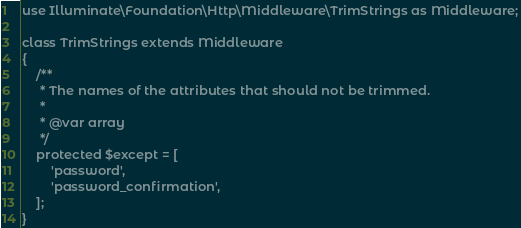<code> <loc_0><loc_0><loc_500><loc_500><_PHP_>
use Illuminate\Foundation\Http\Middleware\TrimStrings as Middleware;

class TrimStrings extends Middleware
{
    /**
     * The names of the attributes that should not be trimmed.
     *
     * @var array
     */
    protected $except = [
        'password',
        'password_confirmation',
    ];
}
</code> 